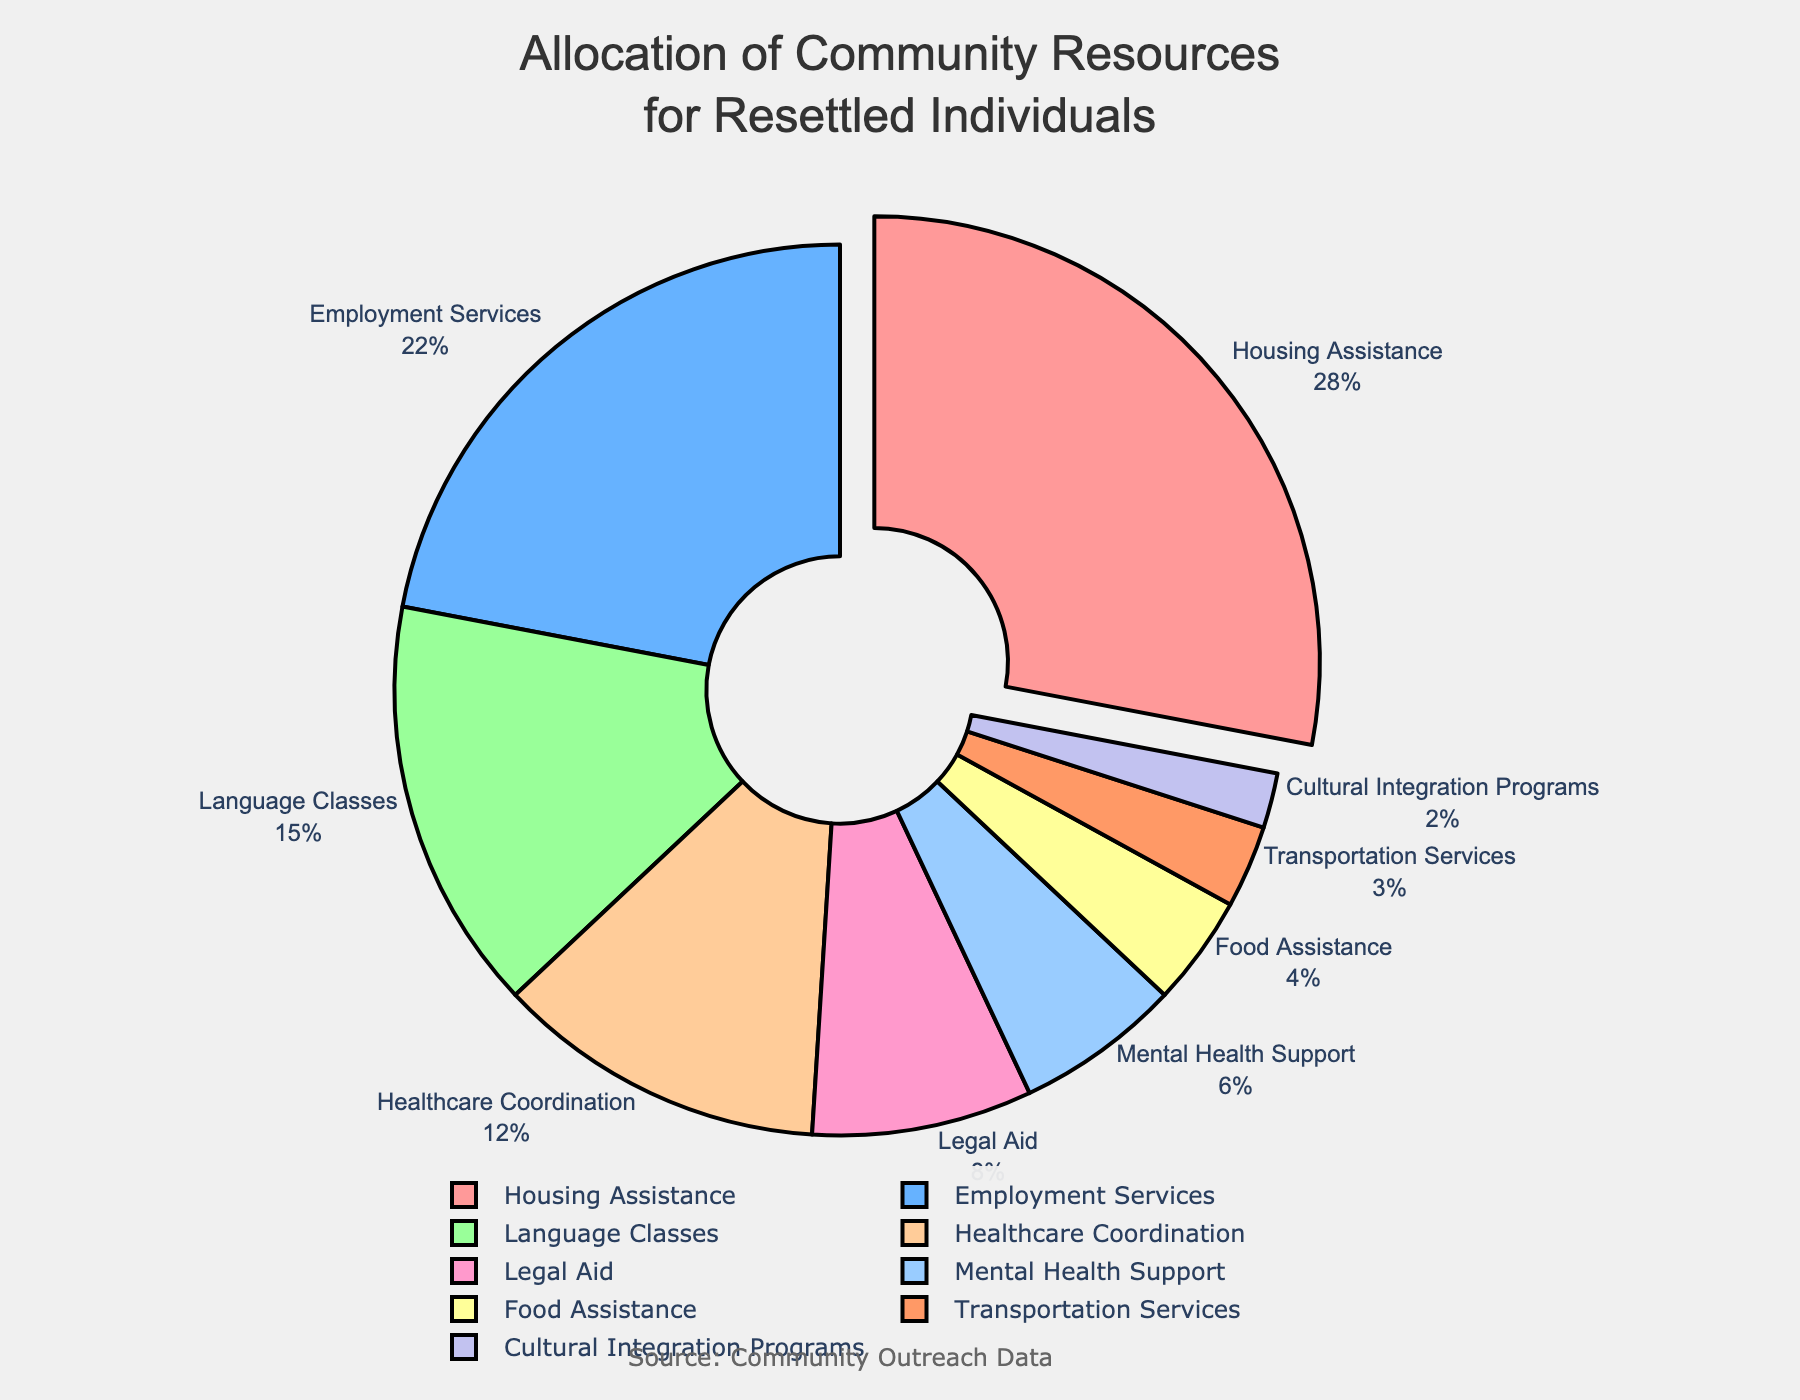Which service category receives the highest allocation of community resources for resettled individuals? By looking at the figure, Housing Assistance has the largest segment and is slightly pulled out.
Answer: Housing Assistance What is the combined percentage for Food Assistance and Transportation Services? The figure shows Food Assistance at 4% and Transportation Services at 3%. Adding these together gives 4% + 3% = 7%.
Answer: 7% Is the percentage allocated to Language Classes greater than that allocated to Legal Aid? By referring to the figure, Language Classes are 15% while Legal Aid is 8%. 15% is greater than 8%.
Answer: Yes How much larger is the allocation for Employment Services compared to Mental Health Support? The allocation for Employment Services is 22% and for Mental Health Support is 6%. The difference is 22% - 6% = 16%.
Answer: 16% Which two service categories together make up more than half of the total resources? Housing Assistance is 28% and Employment Services is 22%. Together, they total 28% + 22% = 50%. To exceed half, look at the next highest which is Language Classes at 15%. However, only Housing Assistance and Employment Services together make exactly 50%.
Answer: Housing Assistance and Employment Services What percentage of resources is dedicated to programs other than Housing Assistance, Employment Services, and Language Classes? Adding the percentages of Housing Assistance (28%), Employment Services (22%), and Language Classes (15%) gives 28% + 22% + 15% = 65%. Subtract this from 100% to get 100% - 65% = 35%.
Answer: 35% Are Cultural Integration Programs and Transportation Services combined allocated more or less than Mental Health Support? Cultural Integration Programs are 2% and Transportation Services are 3%, summing to 2% + 3% = 5%. Mental Health Support is 6%, which is greater than 5%.
Answer: Less What is the ratio of the allocation between Healthcare Coordination and Legal Aid? The figure shows Healthcare Coordination at 12% and Legal Aid at 8%. The ratio is 12:8, which simplifies to 3:2.
Answer: 3:2 Considering all allocations under 10%, what is their combined percentage? Sum the percentages for Legal Aid (8%), Mental Health Support (6%), Food Assistance (4%), Transportation Services (3%), and Cultural Integration Programs (2%). This gives 8% + 6% + 4% + 3% + 2% = 23%.
Answer: 23% Which color represents Mental Health Support, and where is it positioned in the chart? Mental Health Support is represented by light blue and is located towards the right-middle section of the pie.
Answer: Light blue, right-middle 